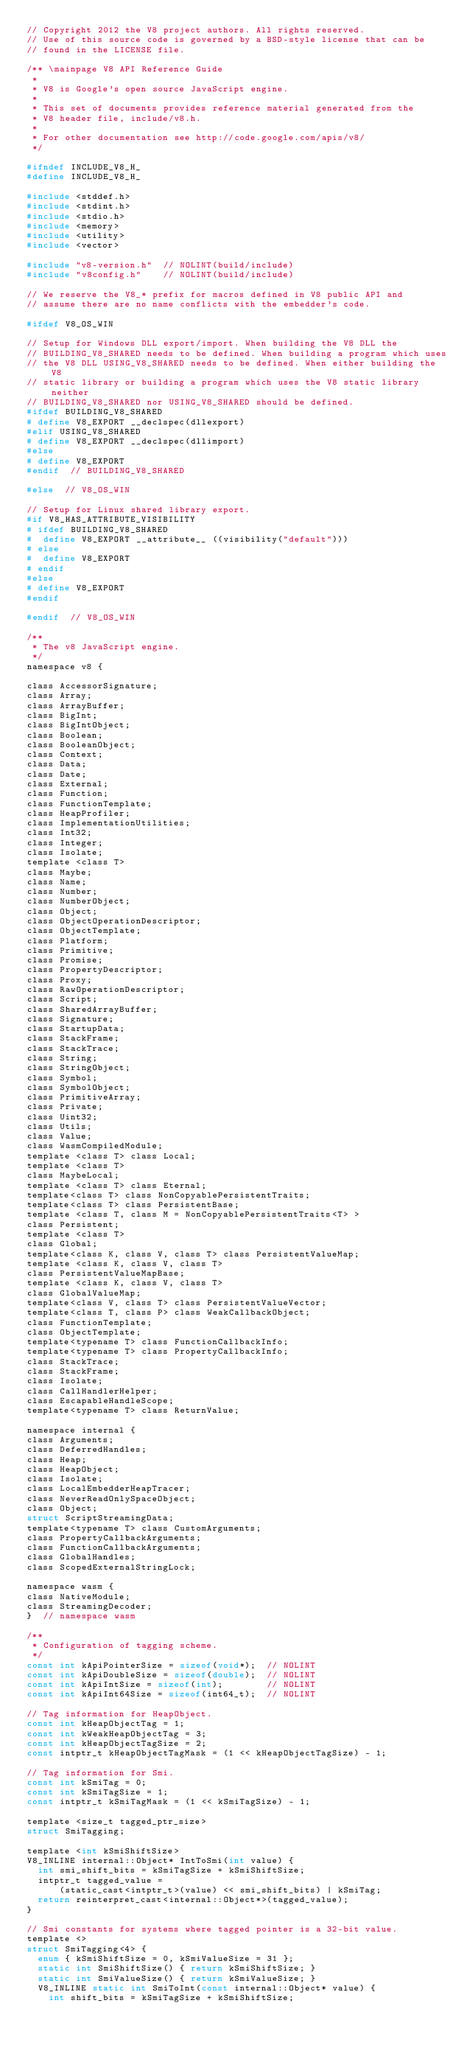Convert code to text. <code><loc_0><loc_0><loc_500><loc_500><_C_>// Copyright 2012 the V8 project authors. All rights reserved.
// Use of this source code is governed by a BSD-style license that can be
// found in the LICENSE file.

/** \mainpage V8 API Reference Guide
 *
 * V8 is Google's open source JavaScript engine.
 *
 * This set of documents provides reference material generated from the
 * V8 header file, include/v8.h.
 *
 * For other documentation see http://code.google.com/apis/v8/
 */

#ifndef INCLUDE_V8_H_
#define INCLUDE_V8_H_

#include <stddef.h>
#include <stdint.h>
#include <stdio.h>
#include <memory>
#include <utility>
#include <vector>

#include "v8-version.h"  // NOLINT(build/include)
#include "v8config.h"    // NOLINT(build/include)

// We reserve the V8_* prefix for macros defined in V8 public API and
// assume there are no name conflicts with the embedder's code.

#ifdef V8_OS_WIN

// Setup for Windows DLL export/import. When building the V8 DLL the
// BUILDING_V8_SHARED needs to be defined. When building a program which uses
// the V8 DLL USING_V8_SHARED needs to be defined. When either building the V8
// static library or building a program which uses the V8 static library neither
// BUILDING_V8_SHARED nor USING_V8_SHARED should be defined.
#ifdef BUILDING_V8_SHARED
# define V8_EXPORT __declspec(dllexport)
#elif USING_V8_SHARED
# define V8_EXPORT __declspec(dllimport)
#else
# define V8_EXPORT
#endif  // BUILDING_V8_SHARED

#else  // V8_OS_WIN

// Setup for Linux shared library export.
#if V8_HAS_ATTRIBUTE_VISIBILITY
# ifdef BUILDING_V8_SHARED
#  define V8_EXPORT __attribute__ ((visibility("default")))
# else
#  define V8_EXPORT
# endif
#else
# define V8_EXPORT
#endif

#endif  // V8_OS_WIN

/**
 * The v8 JavaScript engine.
 */
namespace v8 {

class AccessorSignature;
class Array;
class ArrayBuffer;
class BigInt;
class BigIntObject;
class Boolean;
class BooleanObject;
class Context;
class Data;
class Date;
class External;
class Function;
class FunctionTemplate;
class HeapProfiler;
class ImplementationUtilities;
class Int32;
class Integer;
class Isolate;
template <class T>
class Maybe;
class Name;
class Number;
class NumberObject;
class Object;
class ObjectOperationDescriptor;
class ObjectTemplate;
class Platform;
class Primitive;
class Promise;
class PropertyDescriptor;
class Proxy;
class RawOperationDescriptor;
class Script;
class SharedArrayBuffer;
class Signature;
class StartupData;
class StackFrame;
class StackTrace;
class String;
class StringObject;
class Symbol;
class SymbolObject;
class PrimitiveArray;
class Private;
class Uint32;
class Utils;
class Value;
class WasmCompiledModule;
template <class T> class Local;
template <class T>
class MaybeLocal;
template <class T> class Eternal;
template<class T> class NonCopyablePersistentTraits;
template<class T> class PersistentBase;
template <class T, class M = NonCopyablePersistentTraits<T> >
class Persistent;
template <class T>
class Global;
template<class K, class V, class T> class PersistentValueMap;
template <class K, class V, class T>
class PersistentValueMapBase;
template <class K, class V, class T>
class GlobalValueMap;
template<class V, class T> class PersistentValueVector;
template<class T, class P> class WeakCallbackObject;
class FunctionTemplate;
class ObjectTemplate;
template<typename T> class FunctionCallbackInfo;
template<typename T> class PropertyCallbackInfo;
class StackTrace;
class StackFrame;
class Isolate;
class CallHandlerHelper;
class EscapableHandleScope;
template<typename T> class ReturnValue;

namespace internal {
class Arguments;
class DeferredHandles;
class Heap;
class HeapObject;
class Isolate;
class LocalEmbedderHeapTracer;
class NeverReadOnlySpaceObject;
class Object;
struct ScriptStreamingData;
template<typename T> class CustomArguments;
class PropertyCallbackArguments;
class FunctionCallbackArguments;
class GlobalHandles;
class ScopedExternalStringLock;

namespace wasm {
class NativeModule;
class StreamingDecoder;
}  // namespace wasm

/**
 * Configuration of tagging scheme.
 */
const int kApiPointerSize = sizeof(void*);  // NOLINT
const int kApiDoubleSize = sizeof(double);  // NOLINT
const int kApiIntSize = sizeof(int);        // NOLINT
const int kApiInt64Size = sizeof(int64_t);  // NOLINT

// Tag information for HeapObject.
const int kHeapObjectTag = 1;
const int kWeakHeapObjectTag = 3;
const int kHeapObjectTagSize = 2;
const intptr_t kHeapObjectTagMask = (1 << kHeapObjectTagSize) - 1;

// Tag information for Smi.
const int kSmiTag = 0;
const int kSmiTagSize = 1;
const intptr_t kSmiTagMask = (1 << kSmiTagSize) - 1;

template <size_t tagged_ptr_size>
struct SmiTagging;

template <int kSmiShiftSize>
V8_INLINE internal::Object* IntToSmi(int value) {
  int smi_shift_bits = kSmiTagSize + kSmiShiftSize;
  intptr_t tagged_value =
      (static_cast<intptr_t>(value) << smi_shift_bits) | kSmiTag;
  return reinterpret_cast<internal::Object*>(tagged_value);
}

// Smi constants for systems where tagged pointer is a 32-bit value.
template <>
struct SmiTagging<4> {
  enum { kSmiShiftSize = 0, kSmiValueSize = 31 };
  static int SmiShiftSize() { return kSmiShiftSize; }
  static int SmiValueSize() { return kSmiValueSize; }
  V8_INLINE static int SmiToInt(const internal::Object* value) {
    int shift_bits = kSmiTagSize + kSmiShiftSize;</code> 